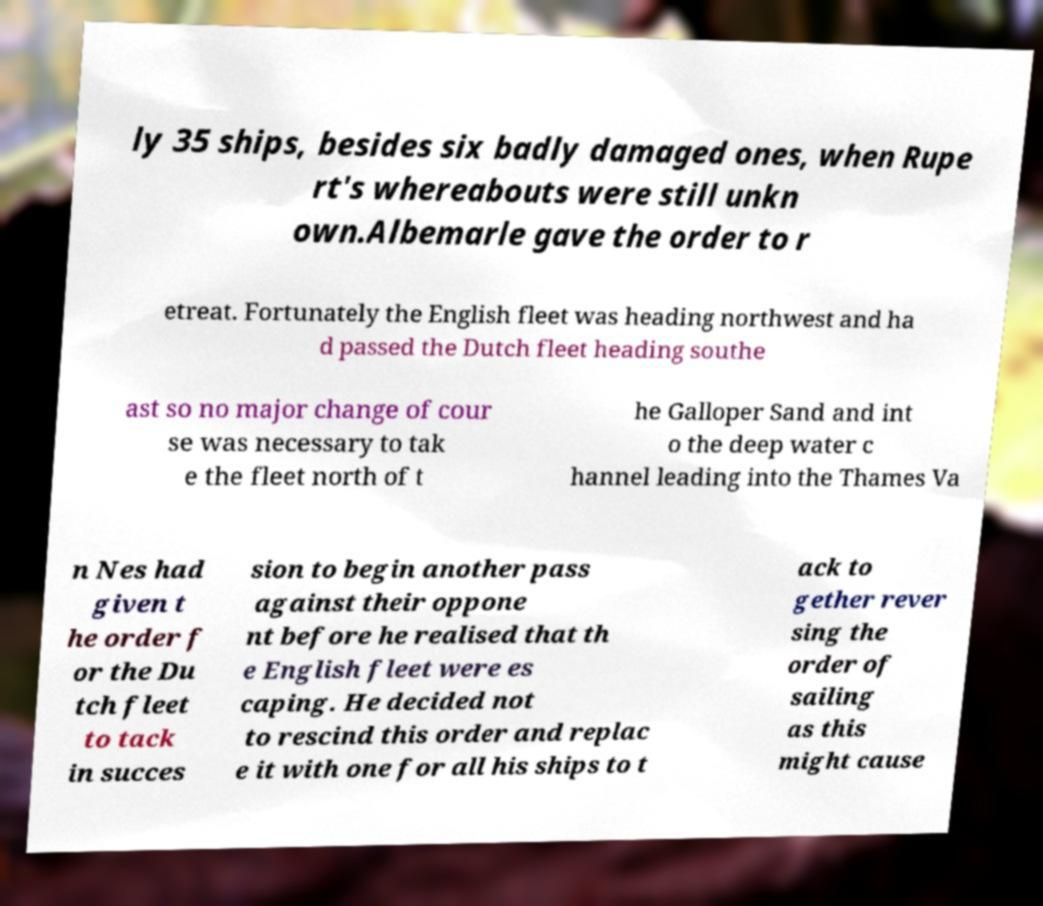Can you read and provide the text displayed in the image?This photo seems to have some interesting text. Can you extract and type it out for me? ly 35 ships, besides six badly damaged ones, when Rupe rt's whereabouts were still unkn own.Albemarle gave the order to r etreat. Fortunately the English fleet was heading northwest and ha d passed the Dutch fleet heading southe ast so no major change of cour se was necessary to tak e the fleet north of t he Galloper Sand and int o the deep water c hannel leading into the Thames Va n Nes had given t he order f or the Du tch fleet to tack in succes sion to begin another pass against their oppone nt before he realised that th e English fleet were es caping. He decided not to rescind this order and replac e it with one for all his ships to t ack to gether rever sing the order of sailing as this might cause 